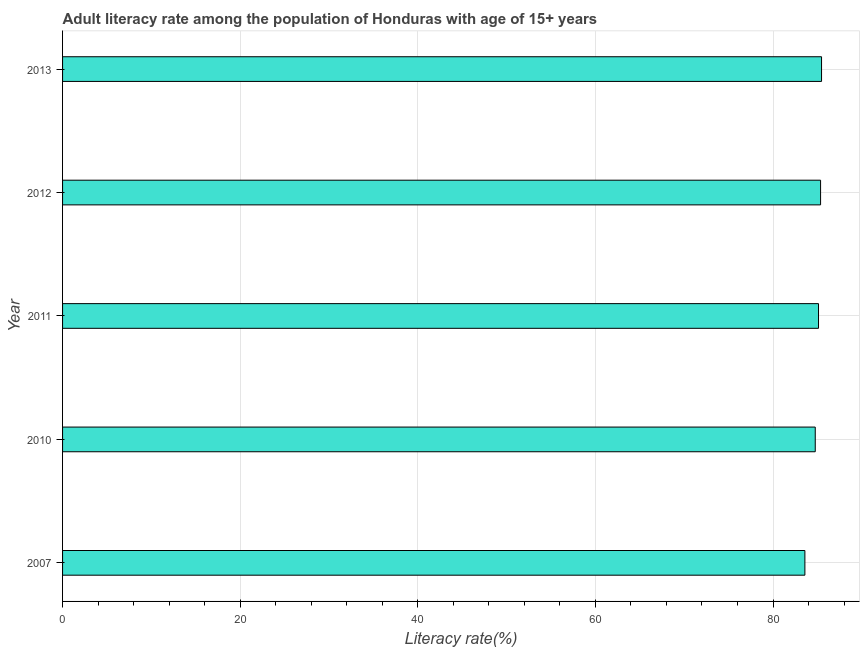Does the graph contain any zero values?
Your answer should be very brief. No. Does the graph contain grids?
Give a very brief answer. Yes. What is the title of the graph?
Make the answer very short. Adult literacy rate among the population of Honduras with age of 15+ years. What is the label or title of the X-axis?
Your answer should be very brief. Literacy rate(%). What is the adult literacy rate in 2007?
Provide a short and direct response. 83.59. Across all years, what is the maximum adult literacy rate?
Your answer should be very brief. 85.46. Across all years, what is the minimum adult literacy rate?
Offer a terse response. 83.59. In which year was the adult literacy rate maximum?
Provide a short and direct response. 2013. What is the sum of the adult literacy rate?
Make the answer very short. 424.29. What is the difference between the adult literacy rate in 2010 and 2011?
Offer a very short reply. -0.37. What is the average adult literacy rate per year?
Make the answer very short. 84.86. What is the median adult literacy rate?
Provide a short and direct response. 85.12. Do a majority of the years between 2010 and 2012 (inclusive) have adult literacy rate greater than 32 %?
Your response must be concise. Yes. Is the difference between the adult literacy rate in 2007 and 2013 greater than the difference between any two years?
Ensure brevity in your answer.  Yes. What is the difference between the highest and the second highest adult literacy rate?
Your response must be concise. 0.11. Is the sum of the adult literacy rate in 2011 and 2012 greater than the maximum adult literacy rate across all years?
Keep it short and to the point. Yes. What is the difference between the highest and the lowest adult literacy rate?
Keep it short and to the point. 1.88. Are all the bars in the graph horizontal?
Keep it short and to the point. Yes. What is the difference between two consecutive major ticks on the X-axis?
Your response must be concise. 20. Are the values on the major ticks of X-axis written in scientific E-notation?
Ensure brevity in your answer.  No. What is the Literacy rate(%) in 2007?
Make the answer very short. 83.59. What is the Literacy rate(%) of 2010?
Offer a very short reply. 84.76. What is the Literacy rate(%) of 2011?
Keep it short and to the point. 85.12. What is the Literacy rate(%) in 2012?
Keep it short and to the point. 85.36. What is the Literacy rate(%) in 2013?
Provide a succinct answer. 85.46. What is the difference between the Literacy rate(%) in 2007 and 2010?
Keep it short and to the point. -1.17. What is the difference between the Literacy rate(%) in 2007 and 2011?
Keep it short and to the point. -1.53. What is the difference between the Literacy rate(%) in 2007 and 2012?
Your response must be concise. -1.77. What is the difference between the Literacy rate(%) in 2007 and 2013?
Your answer should be very brief. -1.88. What is the difference between the Literacy rate(%) in 2010 and 2011?
Make the answer very short. -0.37. What is the difference between the Literacy rate(%) in 2010 and 2012?
Give a very brief answer. -0.6. What is the difference between the Literacy rate(%) in 2010 and 2013?
Provide a succinct answer. -0.71. What is the difference between the Literacy rate(%) in 2011 and 2012?
Your answer should be compact. -0.23. What is the difference between the Literacy rate(%) in 2011 and 2013?
Your answer should be compact. -0.34. What is the difference between the Literacy rate(%) in 2012 and 2013?
Your response must be concise. -0.11. What is the ratio of the Literacy rate(%) in 2007 to that in 2011?
Your answer should be compact. 0.98. What is the ratio of the Literacy rate(%) in 2007 to that in 2013?
Offer a terse response. 0.98. What is the ratio of the Literacy rate(%) in 2010 to that in 2013?
Your answer should be compact. 0.99. What is the ratio of the Literacy rate(%) in 2011 to that in 2013?
Give a very brief answer. 1. 